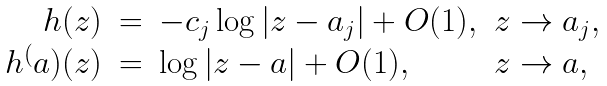<formula> <loc_0><loc_0><loc_500><loc_500>\begin{array} { r c l l } h ( z ) & = & - c _ { j } \log | z - a _ { j } | + O ( 1 ) , & z \rightarrow a _ { j } , \\ h ^ { ( } a ) ( z ) & = & \log | z - a | + O ( 1 ) , & z \rightarrow a , \end{array}</formula> 